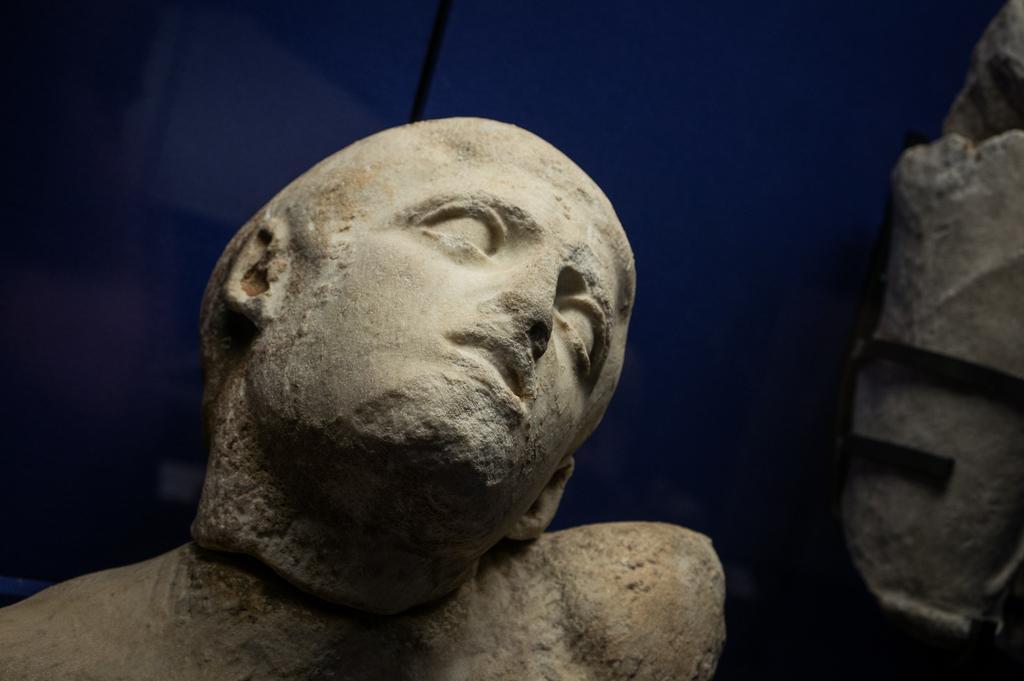How would you summarize this image in a sentence or two? In this image I can see there are sculptures and at the back it looks like a cloth. 